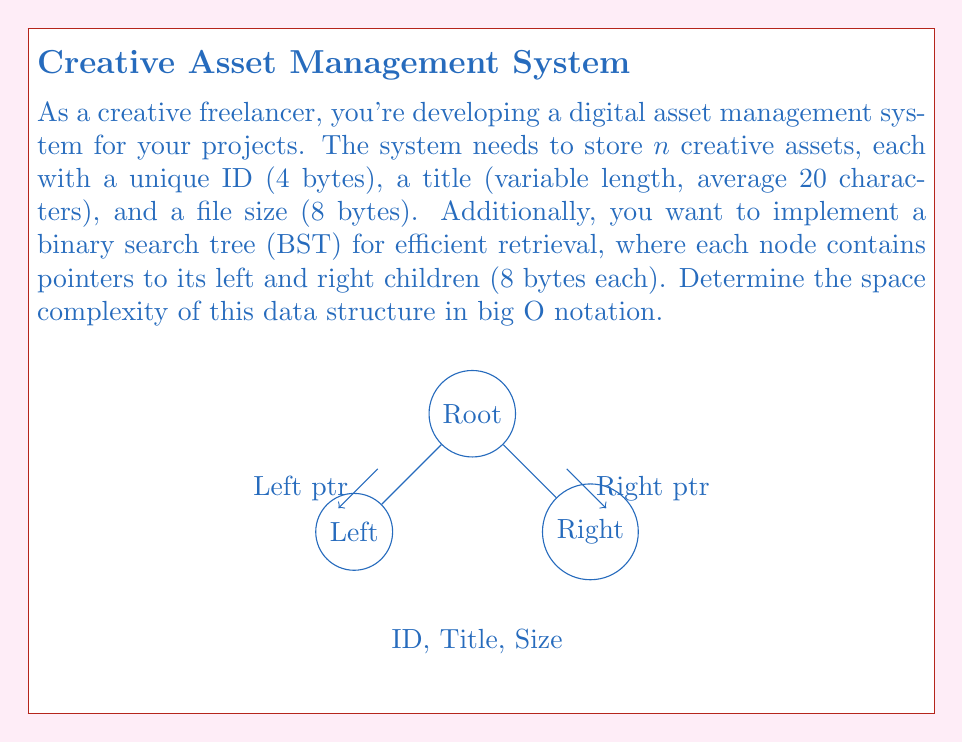Can you answer this question? To determine the space complexity, let's break down the components and analyze their space requirements:

1. For each asset:
   - ID: 4 bytes
   - Title: Variable length, but on average 20 characters. Assuming 1 byte per character: 20 bytes
   - File size: 8 bytes
   - Left child pointer: 8 bytes
   - Right child pointer: 8 bytes

   Total per asset: $4 + 20 + 8 + 8 + 8 = 48$ bytes

2. For $n$ assets, the total space required is $48n$ bytes.

3. The binary search tree structure doesn't add any additional space complexity, as it uses the existing nodes (assets) to form the tree.

4. The space complexity is linear with respect to the number of assets, as each asset contributes a constant amount of space.

5. In big O notation, we express this as $O(n)$, where $n$ is the number of assets.

Note: We don't consider the constant factor (48 bytes per asset) in the big O notation, as it focuses on the growth rate rather than the exact space used.
Answer: $O(n)$ 